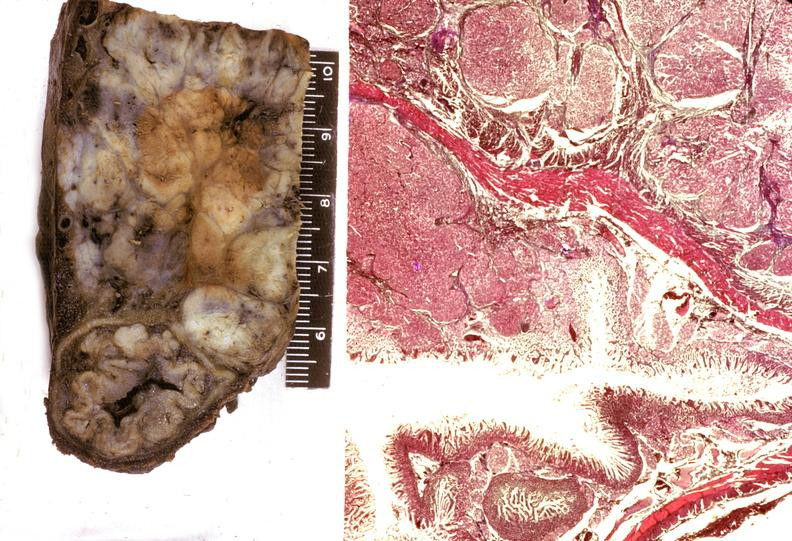what does this image show?
Answer the question using a single word or phrase. Islet cell carcinoma 